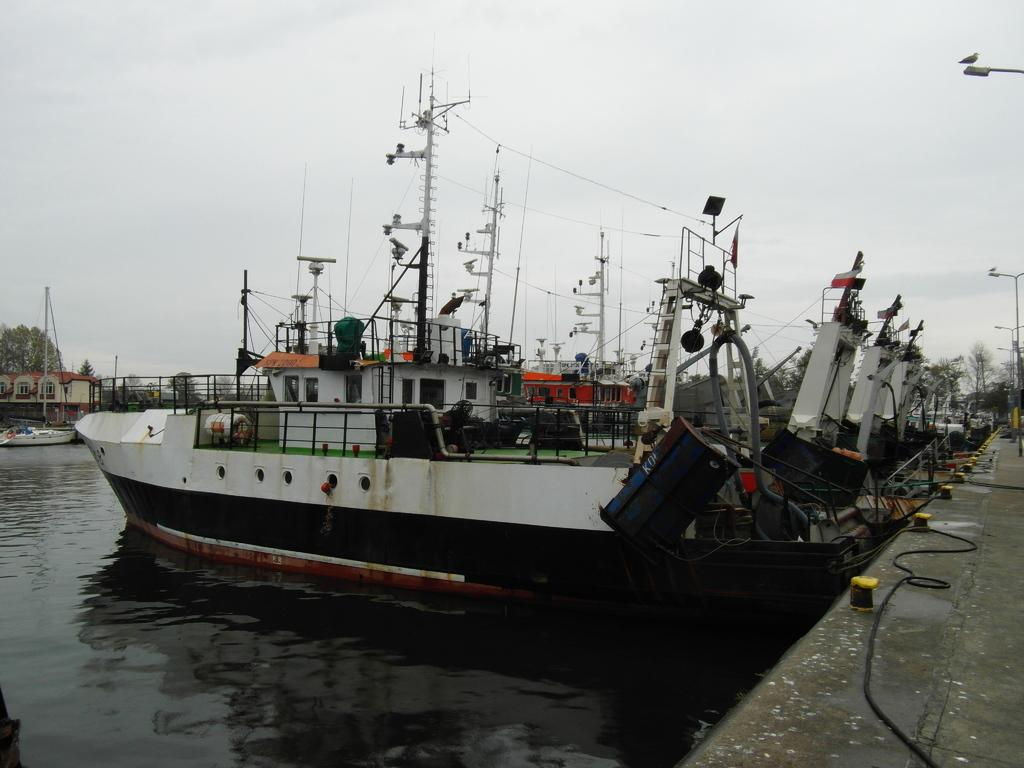What is the primary element in the image? There is water in the image. What is floating on the surface of the water? There are boats on the surface of the water. What structure can be seen in the image? There is a bridge in the image. What are the poles used for in the image? The poles are likely used for mooring or anchoring the boats. What are the ropes used for in the image? The ropes are likely used for tying or securing the boats. What type of vegetation is present in the image? There are trees in the image. What type of man-made structures are present in the image? There are buildings in the image. What is visible in the background of the image? The sky is visible in the background of the image. What type of wheel can be seen on the moon in the image? There is no moon or wheel present in the image. What type of learning is taking place in the image? The image does not depict any learning or educational activity; it is a scene of boats, water, and a bridge. 